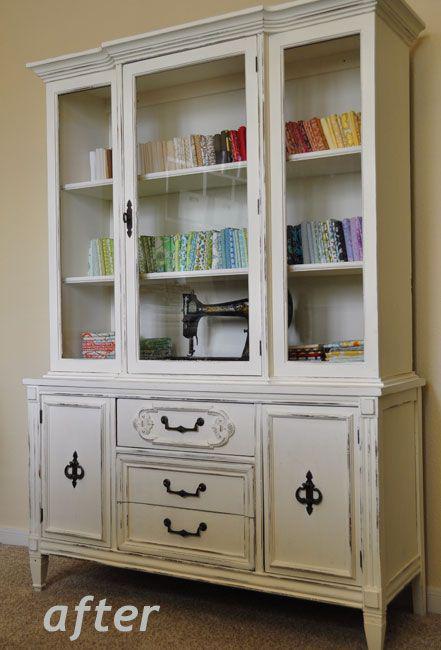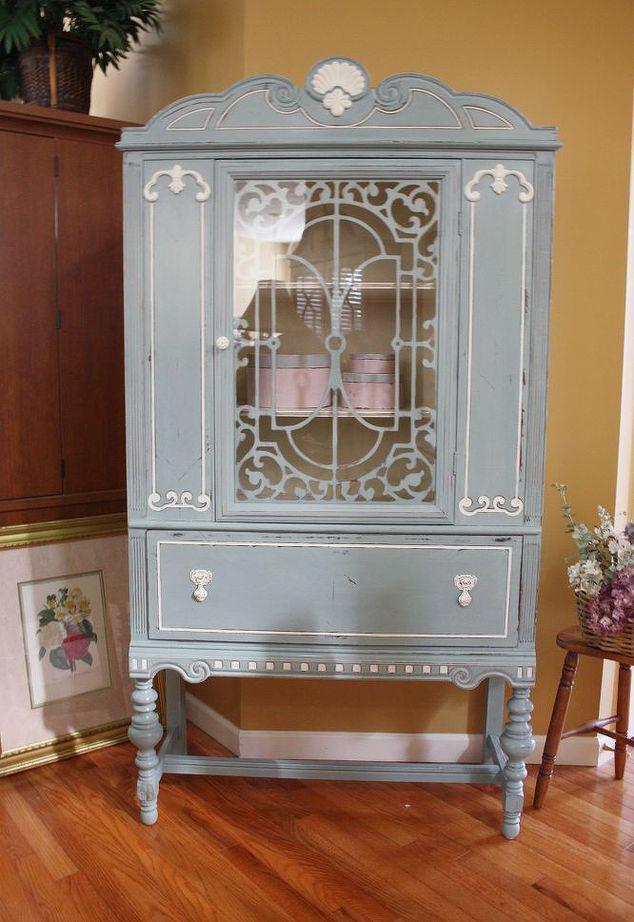The first image is the image on the left, the second image is the image on the right. Analyze the images presented: Is the assertion "There are two cabinets in one of the images." valid? Answer yes or no. No. 